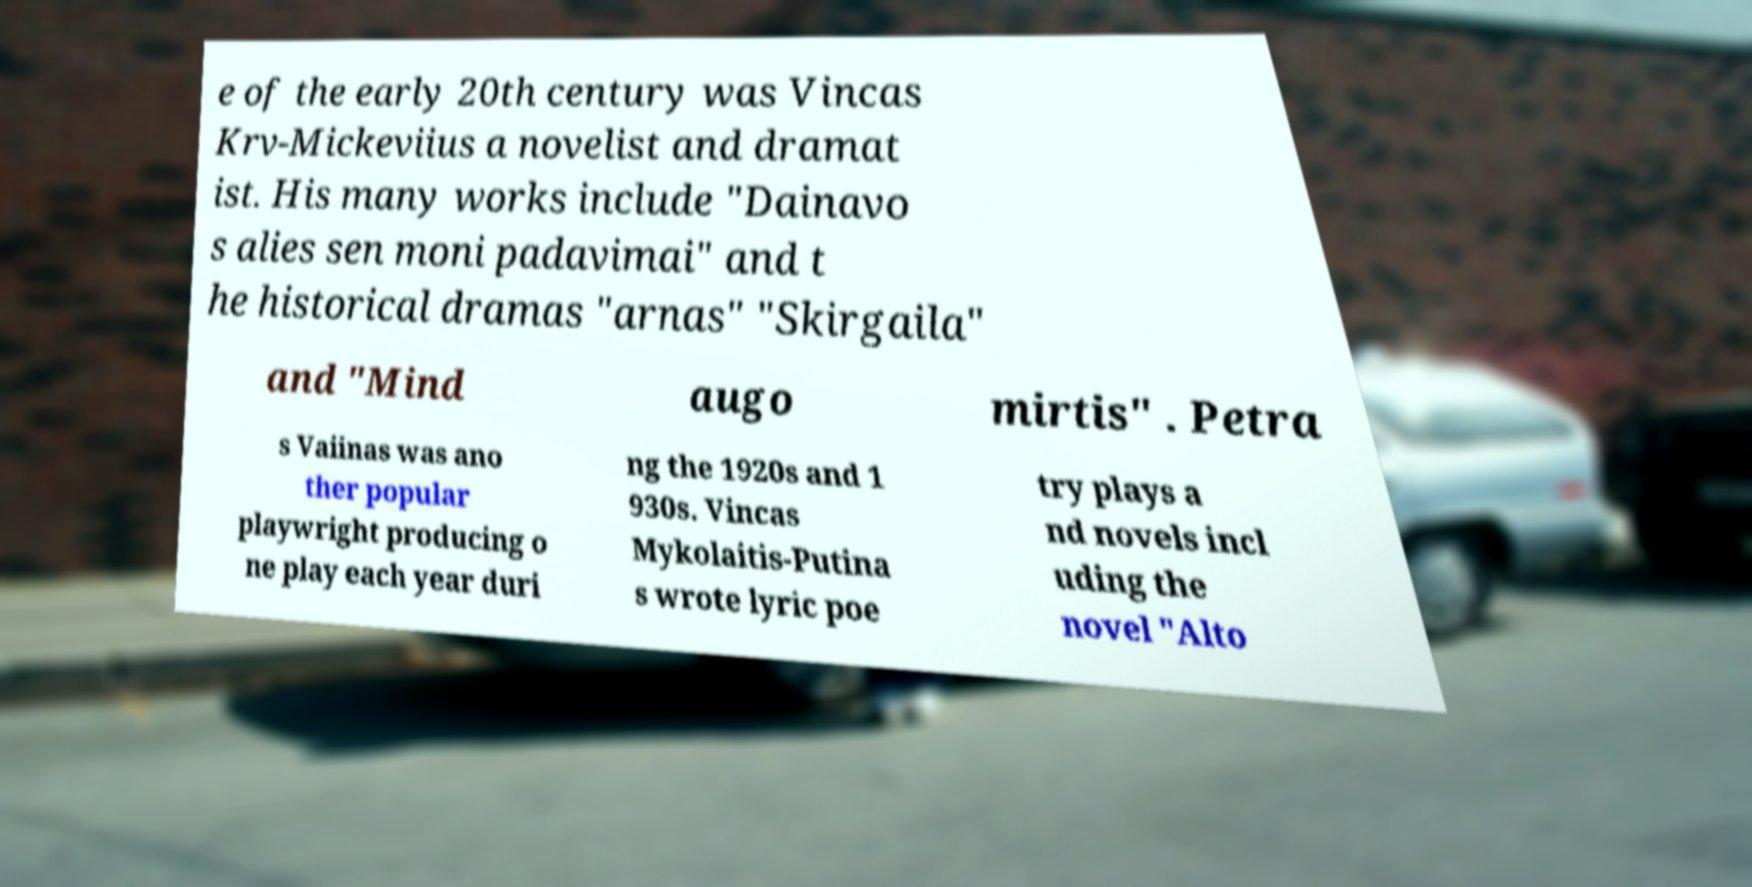Could you assist in decoding the text presented in this image and type it out clearly? e of the early 20th century was Vincas Krv-Mickeviius a novelist and dramat ist. His many works include "Dainavo s alies sen moni padavimai" and t he historical dramas "arnas" "Skirgaila" and "Mind augo mirtis" . Petra s Vaiinas was ano ther popular playwright producing o ne play each year duri ng the 1920s and 1 930s. Vincas Mykolaitis-Putina s wrote lyric poe try plays a nd novels incl uding the novel "Alto 